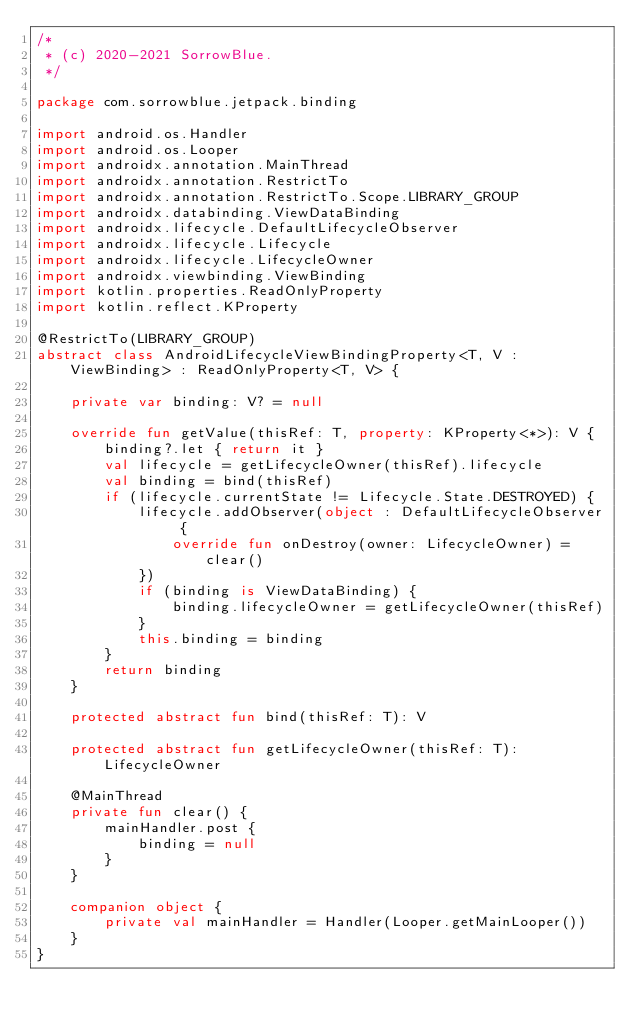<code> <loc_0><loc_0><loc_500><loc_500><_Kotlin_>/*
 * (c) 2020-2021 SorrowBlue.
 */

package com.sorrowblue.jetpack.binding

import android.os.Handler
import android.os.Looper
import androidx.annotation.MainThread
import androidx.annotation.RestrictTo
import androidx.annotation.RestrictTo.Scope.LIBRARY_GROUP
import androidx.databinding.ViewDataBinding
import androidx.lifecycle.DefaultLifecycleObserver
import androidx.lifecycle.Lifecycle
import androidx.lifecycle.LifecycleOwner
import androidx.viewbinding.ViewBinding
import kotlin.properties.ReadOnlyProperty
import kotlin.reflect.KProperty

@RestrictTo(LIBRARY_GROUP)
abstract class AndroidLifecycleViewBindingProperty<T, V : ViewBinding> : ReadOnlyProperty<T, V> {

    private var binding: V? = null

    override fun getValue(thisRef: T, property: KProperty<*>): V {
        binding?.let { return it }
        val lifecycle = getLifecycleOwner(thisRef).lifecycle
        val binding = bind(thisRef)
        if (lifecycle.currentState != Lifecycle.State.DESTROYED) {
            lifecycle.addObserver(object : DefaultLifecycleObserver {
                override fun onDestroy(owner: LifecycleOwner) = clear()
            })
            if (binding is ViewDataBinding) {
                binding.lifecycleOwner = getLifecycleOwner(thisRef)
            }
            this.binding = binding
        }
        return binding
    }

    protected abstract fun bind(thisRef: T): V

    protected abstract fun getLifecycleOwner(thisRef: T): LifecycleOwner

    @MainThread
    private fun clear() {
        mainHandler.post {
            binding = null
        }
    }

    companion object {
        private val mainHandler = Handler(Looper.getMainLooper())
    }
}
</code> 